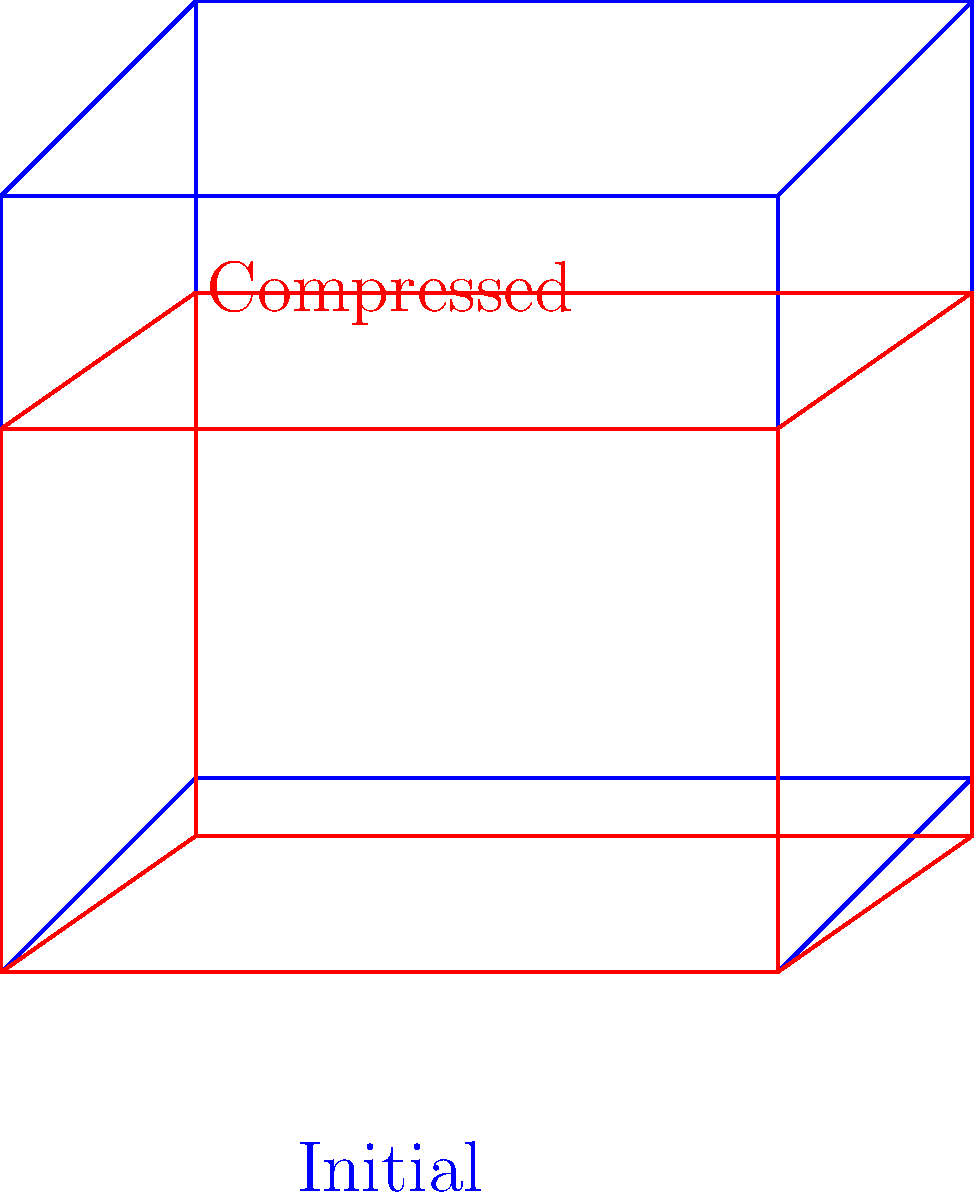In a cubic crystal lattice subjected to extreme pressure along one axis, the lattice experiences uniaxial compression. If the original lattice constant is $a$ and the compression factor is $k$ (where $0 < k < 1$), what is the new volume of the unit cell in terms of $a$ and $k$, and how does the density of the material change? Let's approach this step-by-step:

1) In the original cubic lattice, the volume of the unit cell is:
   $$V_1 = a^3$$

2) After compression along one axis (let's say the z-axis), the new dimensions are:
   x = a
   y = a
   z = ka (where k is the compression factor)

3) The new volume of the unit cell is:
   $$V_2 = a \times a \times ka = ka^3$$

4) The ratio of the new volume to the original volume is:
   $$\frac{V_2}{V_1} = \frac{ka^3}{a^3} = k$$

5) Density is mass per unit volume. If we assume the mass remains constant (no atoms are lost), then:
   $$\rho_1 = \frac{m}{V_1} \quad \text{and} \quad \rho_2 = \frac{m}{V_2}$$

6) The ratio of the new density to the original density is:
   $$\frac{\rho_2}{\rho_1} = \frac{m/V_2}{m/V_1} = \frac{V_1}{V_2} = \frac{1}{k}$$

7) This means the new density is $\frac{1}{k}$ times the original density.
Answer: New volume: $ka^3$; Density change: $\frac{1}{k}$ times original 